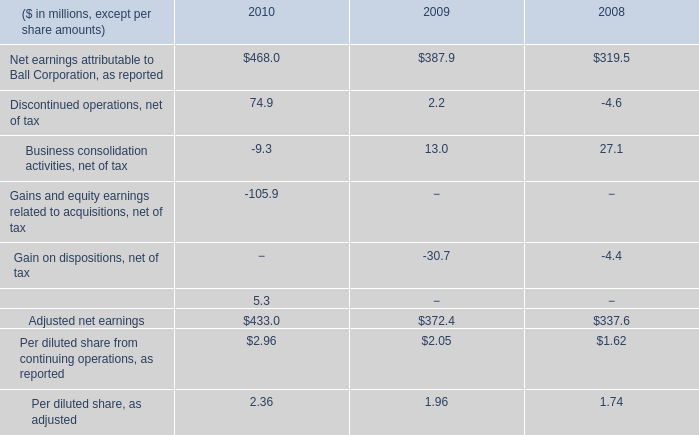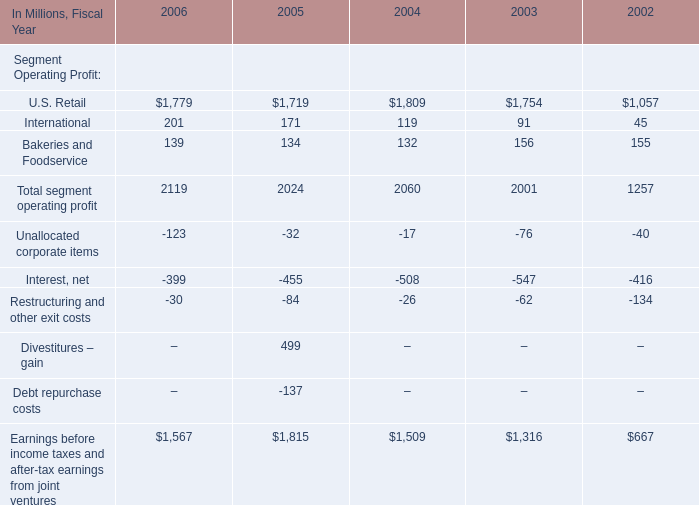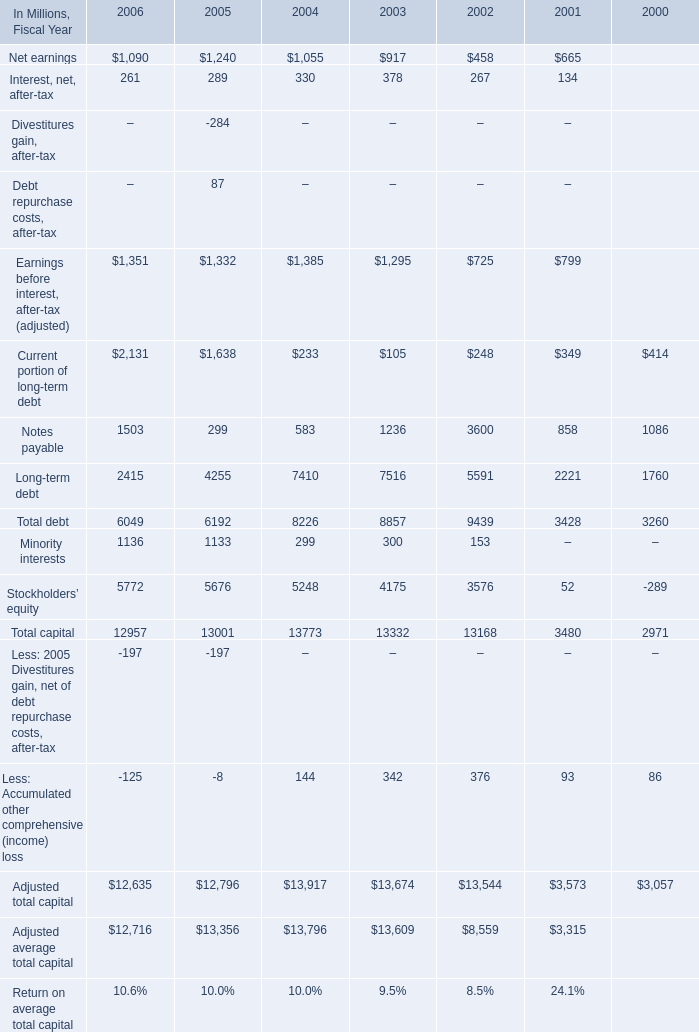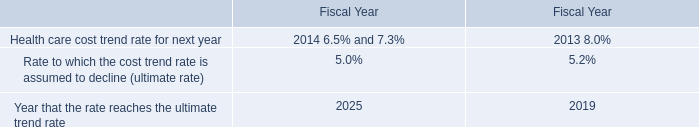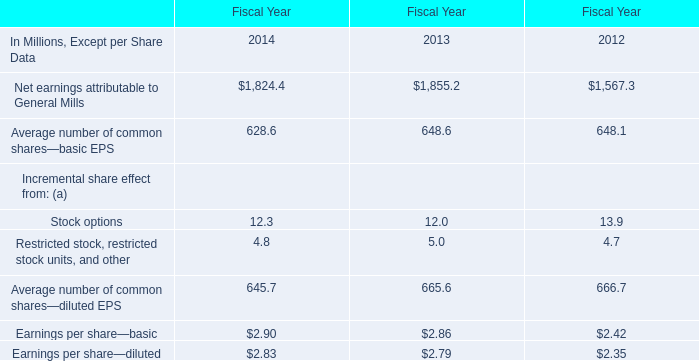What was the average value of Total debt, Minority interests, Stockholders’ equity in 2005 ? (in million) 
Computations: (((6192 + 1133) + 5676) / 3)
Answer: 4333.66667. 